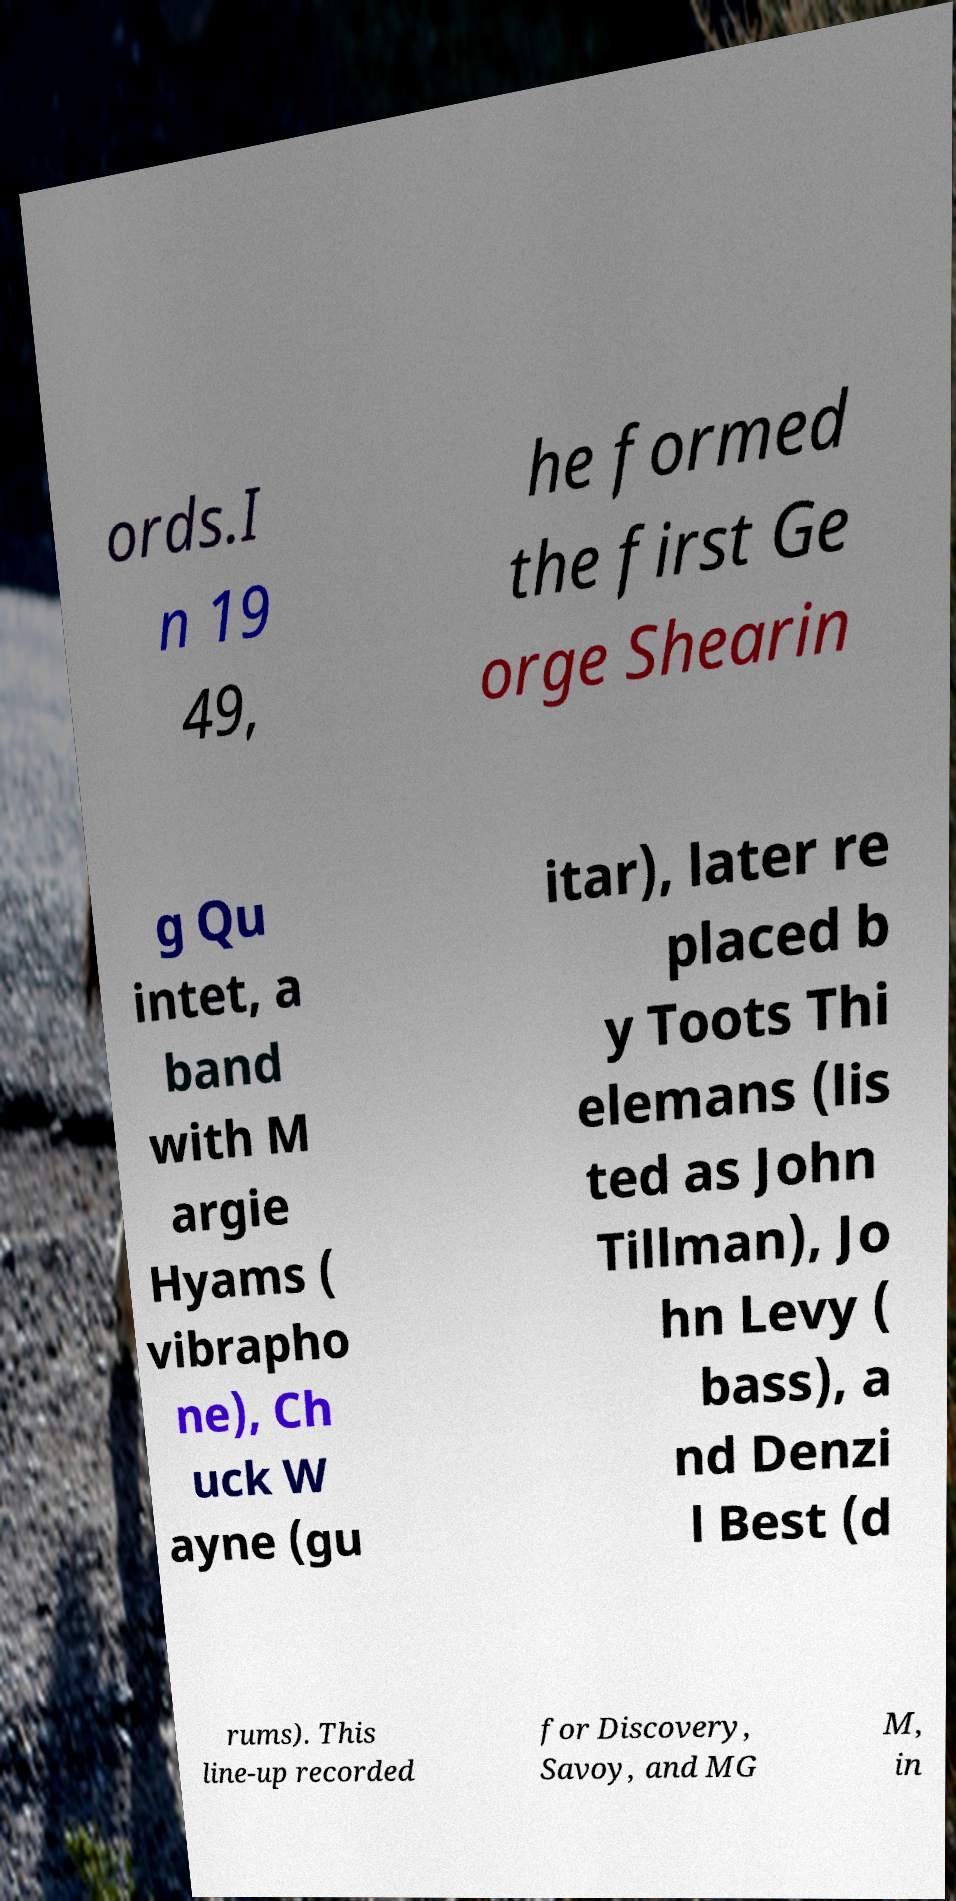Could you assist in decoding the text presented in this image and type it out clearly? ords.I n 19 49, he formed the first Ge orge Shearin g Qu intet, a band with M argie Hyams ( vibrapho ne), Ch uck W ayne (gu itar), later re placed b y Toots Thi elemans (lis ted as John Tillman), Jo hn Levy ( bass), a nd Denzi l Best (d rums). This line-up recorded for Discovery, Savoy, and MG M, in 